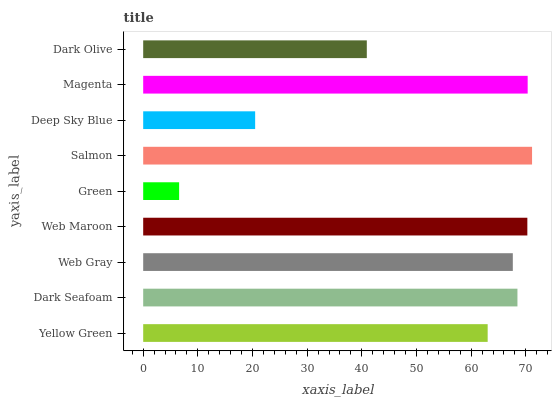Is Green the minimum?
Answer yes or no. Yes. Is Salmon the maximum?
Answer yes or no. Yes. Is Dark Seafoam the minimum?
Answer yes or no. No. Is Dark Seafoam the maximum?
Answer yes or no. No. Is Dark Seafoam greater than Yellow Green?
Answer yes or no. Yes. Is Yellow Green less than Dark Seafoam?
Answer yes or no. Yes. Is Yellow Green greater than Dark Seafoam?
Answer yes or no. No. Is Dark Seafoam less than Yellow Green?
Answer yes or no. No. Is Web Gray the high median?
Answer yes or no. Yes. Is Web Gray the low median?
Answer yes or no. Yes. Is Yellow Green the high median?
Answer yes or no. No. Is Dark Olive the low median?
Answer yes or no. No. 